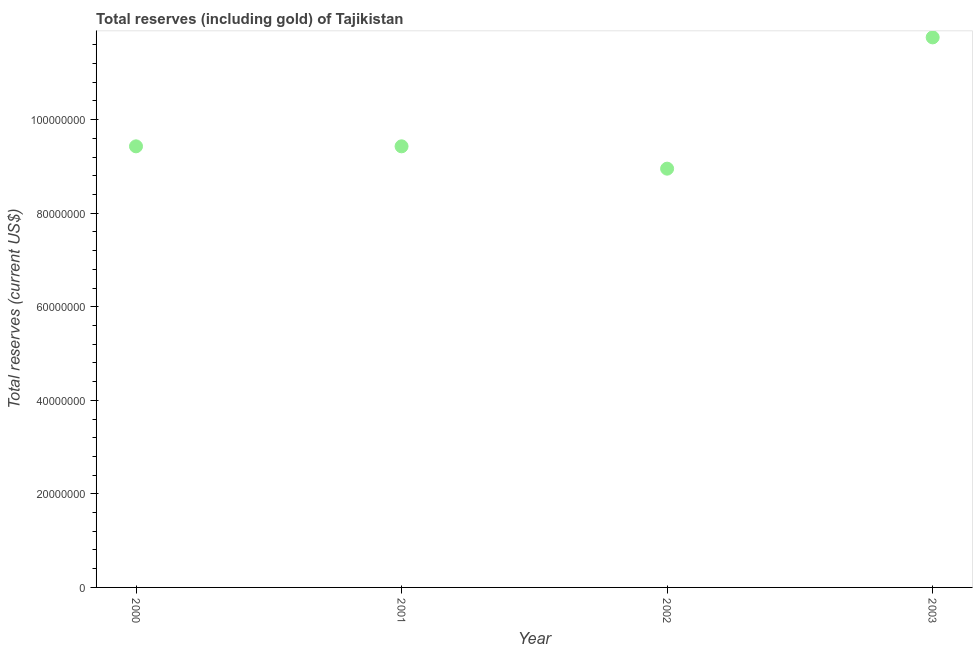What is the total reserves (including gold) in 2000?
Give a very brief answer. 9.43e+07. Across all years, what is the maximum total reserves (including gold)?
Keep it short and to the point. 1.18e+08. Across all years, what is the minimum total reserves (including gold)?
Your answer should be very brief. 8.95e+07. In which year was the total reserves (including gold) maximum?
Your answer should be very brief. 2003. What is the sum of the total reserves (including gold)?
Offer a terse response. 3.96e+08. What is the difference between the total reserves (including gold) in 2000 and 2001?
Make the answer very short. -2061.53. What is the average total reserves (including gold) per year?
Give a very brief answer. 9.89e+07. What is the median total reserves (including gold)?
Your response must be concise. 9.43e+07. In how many years, is the total reserves (including gold) greater than 72000000 US$?
Your answer should be very brief. 4. Do a majority of the years between 2000 and 2003 (inclusive) have total reserves (including gold) greater than 72000000 US$?
Your answer should be compact. Yes. What is the ratio of the total reserves (including gold) in 2001 to that in 2003?
Your answer should be very brief. 0.8. Is the difference between the total reserves (including gold) in 2000 and 2002 greater than the difference between any two years?
Your answer should be compact. No. What is the difference between the highest and the second highest total reserves (including gold)?
Offer a very short reply. 2.33e+07. Is the sum of the total reserves (including gold) in 2000 and 2001 greater than the maximum total reserves (including gold) across all years?
Provide a short and direct response. Yes. What is the difference between the highest and the lowest total reserves (including gold)?
Ensure brevity in your answer.  2.81e+07. Does the total reserves (including gold) monotonically increase over the years?
Offer a very short reply. No. How many years are there in the graph?
Your answer should be compact. 4. What is the difference between two consecutive major ticks on the Y-axis?
Your response must be concise. 2.00e+07. Are the values on the major ticks of Y-axis written in scientific E-notation?
Your response must be concise. No. Does the graph contain any zero values?
Offer a terse response. No. Does the graph contain grids?
Provide a succinct answer. No. What is the title of the graph?
Provide a succinct answer. Total reserves (including gold) of Tajikistan. What is the label or title of the Y-axis?
Give a very brief answer. Total reserves (current US$). What is the Total reserves (current US$) in 2000?
Provide a succinct answer. 9.43e+07. What is the Total reserves (current US$) in 2001?
Provide a succinct answer. 9.43e+07. What is the Total reserves (current US$) in 2002?
Ensure brevity in your answer.  8.95e+07. What is the Total reserves (current US$) in 2003?
Make the answer very short. 1.18e+08. What is the difference between the Total reserves (current US$) in 2000 and 2001?
Provide a short and direct response. -2061.53. What is the difference between the Total reserves (current US$) in 2000 and 2002?
Offer a terse response. 4.77e+06. What is the difference between the Total reserves (current US$) in 2000 and 2003?
Ensure brevity in your answer.  -2.33e+07. What is the difference between the Total reserves (current US$) in 2001 and 2002?
Ensure brevity in your answer.  4.77e+06. What is the difference between the Total reserves (current US$) in 2001 and 2003?
Your answer should be very brief. -2.33e+07. What is the difference between the Total reserves (current US$) in 2002 and 2003?
Keep it short and to the point. -2.81e+07. What is the ratio of the Total reserves (current US$) in 2000 to that in 2002?
Give a very brief answer. 1.05. What is the ratio of the Total reserves (current US$) in 2000 to that in 2003?
Make the answer very short. 0.8. What is the ratio of the Total reserves (current US$) in 2001 to that in 2002?
Offer a very short reply. 1.05. What is the ratio of the Total reserves (current US$) in 2001 to that in 2003?
Make the answer very short. 0.8. What is the ratio of the Total reserves (current US$) in 2002 to that in 2003?
Keep it short and to the point. 0.76. 